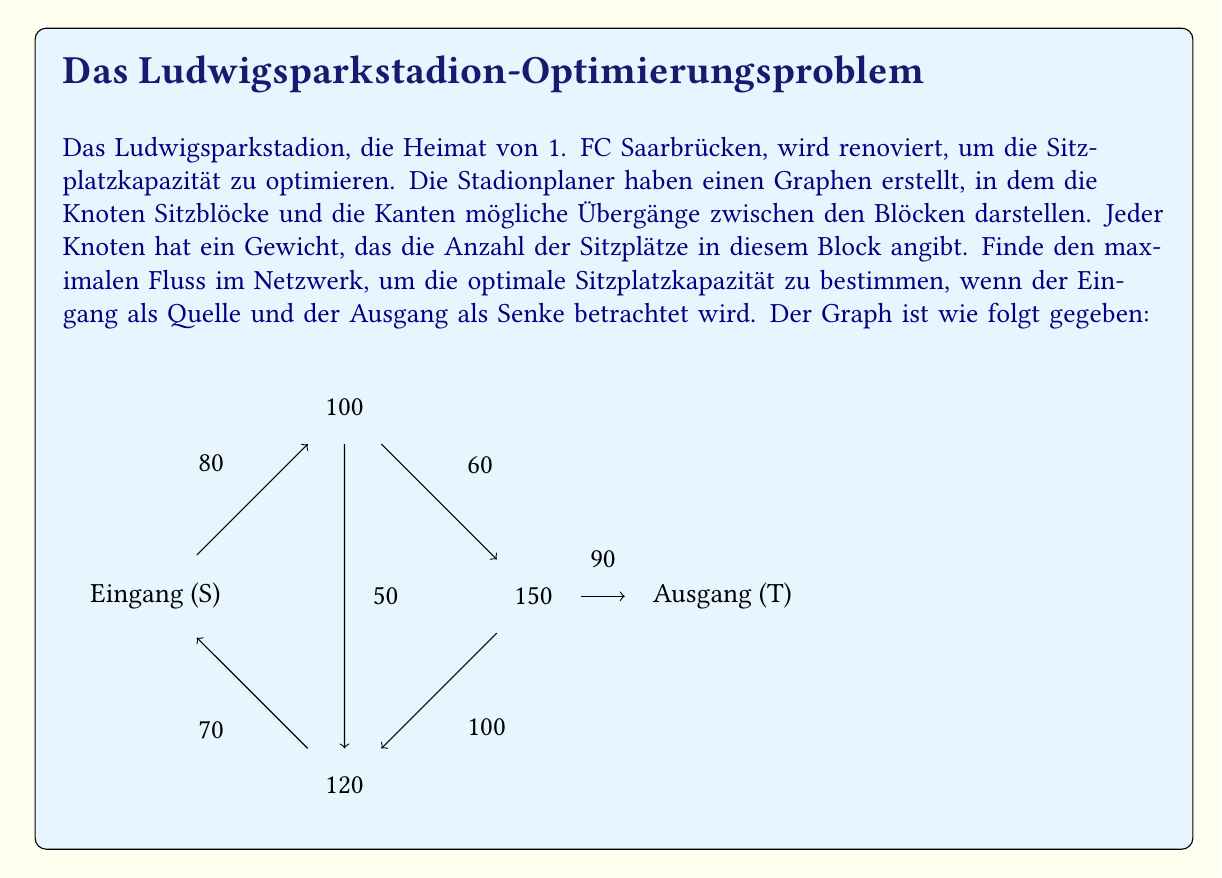Can you solve this math problem? Um dieses Problem zu lösen, verwenden wir den Ford-Fulkerson-Algorithmus zur Berechnung des maximalen Flusses in einem Netzwerk. Hier sind die Schritte:

1) Zunächst stellen wir den Graphen als Adjazenzmatrix dar:

   $$ \begin{bmatrix}
   0 & 80 & 0 & 70 & 0 \\
   0 & 0 & 60 & 50 & 0 \\
   0 & 0 & 0 & 100 & 90 \\
   0 & 0 & 0 & 0 & 0 \\
   0 & 0 & 0 & 0 & 0
   \end{bmatrix} $$

2) Wir beginnen mit einem Fluss von 0 und suchen nach augmentierenden Pfaden:

   a) S -> B -> C -> T (min(80, 60, 90) = 60)
   b) S -> D -> C -> T (min(70, 100, 30) = 30)
   c) S -> B -> D -> C -> T (min(20, 50, 70, 0) = 0)

3) Nach diesen Schritten erhalten wir den maximalen Fluss:
   
   $60 + 30 = 90$

4) Dieser Wert repräsentiert die maximale Anzahl von Fans, die gleichzeitig durch das Stadion fließen können, was der optimalen Sitzplatzkapazität entspricht.

5) Um die tatsächliche Sitzplatzkapazität zu berechnen, addieren wir die Gewichte der inneren Knoten:

   $100 + 150 + 120 = 370$

Dies ist die Gesamtanzahl der Sitzplätze im Stadion.
Answer: Die optimale Sitzplatzkapazität des Ludwigsparkstadions beträgt 370 Sitzplätze, mit einem maximalen Fluss von 90 Fans, die gleichzeitig ein- und ausströmen können. 